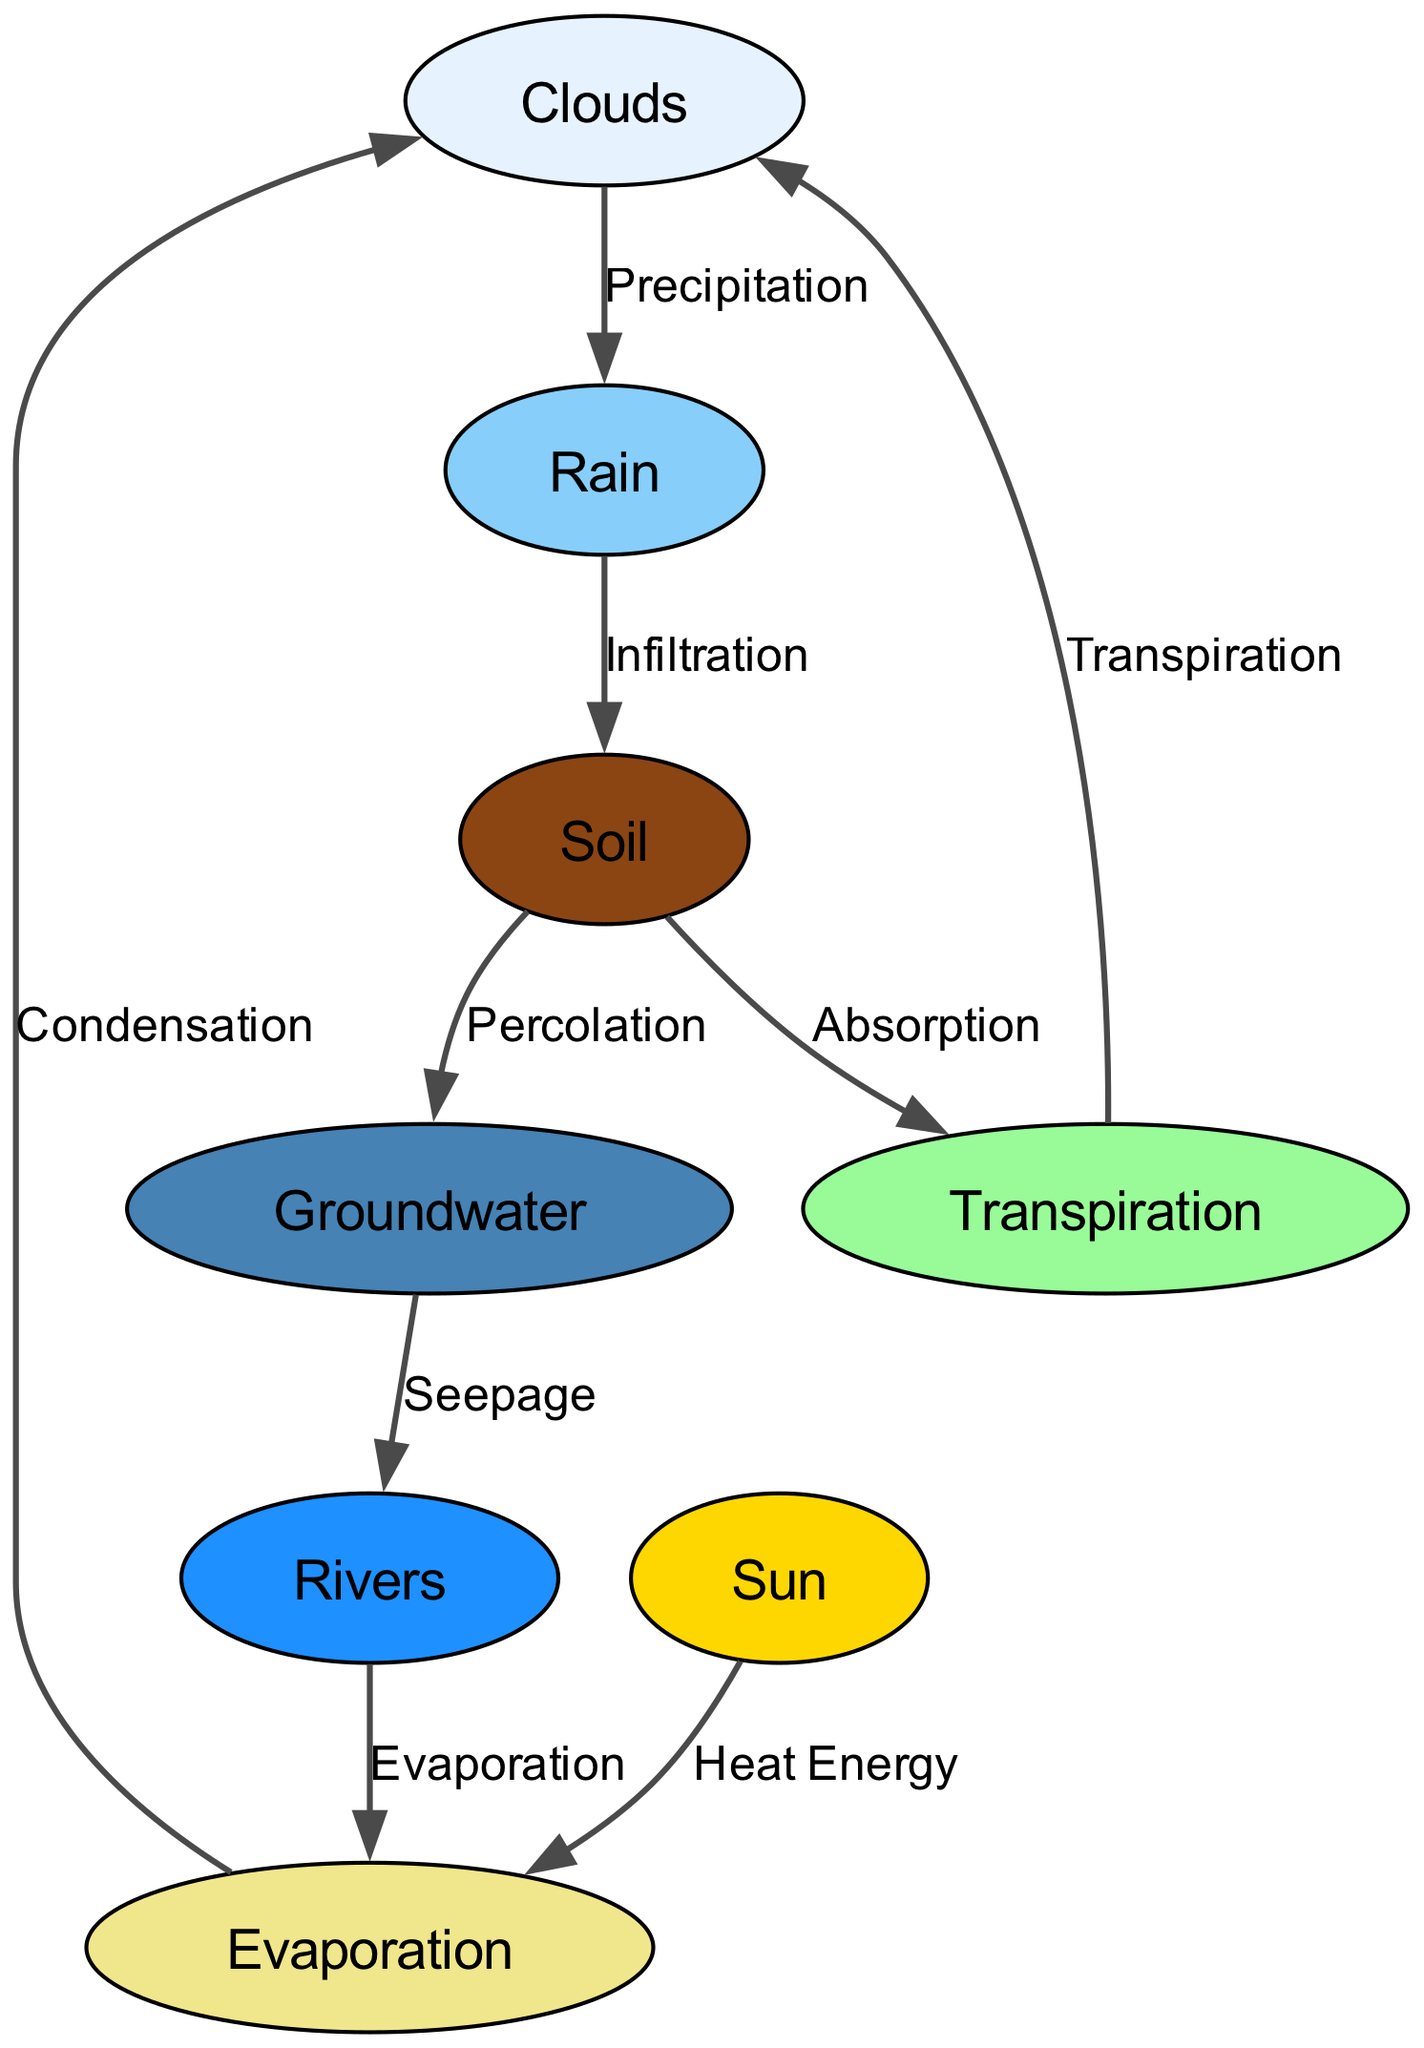What are the nodes in this diagram? The diagram includes multiple nodes representing different components of the water cycle: Clouds, Rain, Soil, Groundwater, Rivers, Evaporation, Transpiration, and Sun.
Answer: Clouds, Rain, Soil, Groundwater, Rivers, Evaporation, Transpiration, Sun How many edges are there in the diagram? The diagram shows connections (edges) between nodes that represent processes in the water cycle. Counting all edges reveals that there are 8 edges connecting the nodes.
Answer: 8 What process connects the clouds to the rain? The edge between the "clouds" node and the "rain" node is labeled "Precipitation," which indicates the process of rain falling from clouds.
Answer: Precipitation What moves water from the river to evaporation? The process indicated by the edge from the "rivers" node to the "evaporation" node is labeled "Evaporation," which describes the transition of water from rivers back to vapor in the atmosphere.
Answer: Evaporation What is the direct relationship between soil and groundwater? The edge between the "soil" node and the "groundwater" node is labeled "Percolation," indicating how water from soil moves down into the groundwater.
Answer: Percolation Which node represents the source of heat energy in the diagram? The "sun" node is directly connected to the "evaporation" node, indicating it provides the heat energy necessary for evaporation to occur.
Answer: Sun How does water return to the clouds after transpiration? The edge leading from the "transpiration" node back to the "clouds" node is labeled "Transpiration," indicating that water vapor released from plants goes back into the atmosphere to form clouds.
Answer: Transpiration What is the flow order from rain to rivers? The flow from "rain" to "soil" (Infiltration), then to "groundwater" (Percolation), and finally to "rivers" (Seepage) shows the order of processes that lead to water reaching rivers.
Answer: Rain → Soil → Groundwater → Rivers 